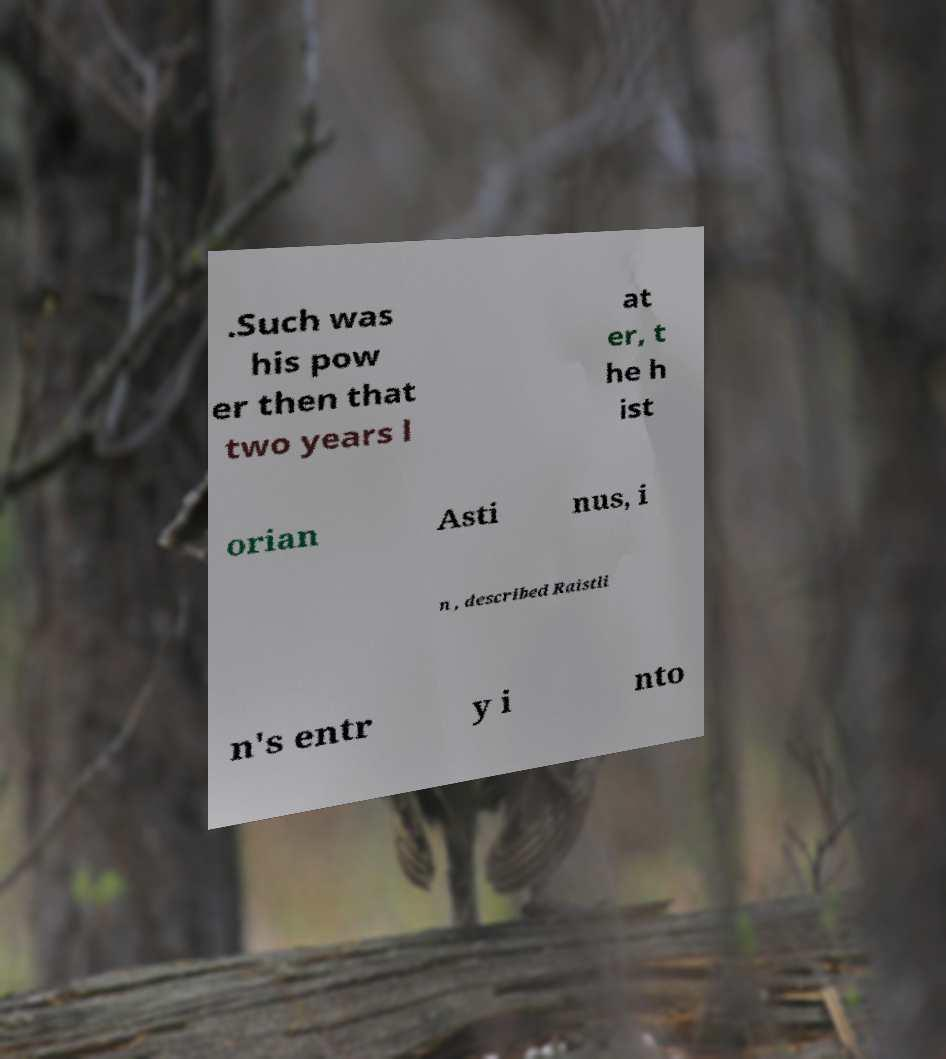There's text embedded in this image that I need extracted. Can you transcribe it verbatim? .Such was his pow er then that two years l at er, t he h ist orian Asti nus, i n , described Raistli n's entr y i nto 